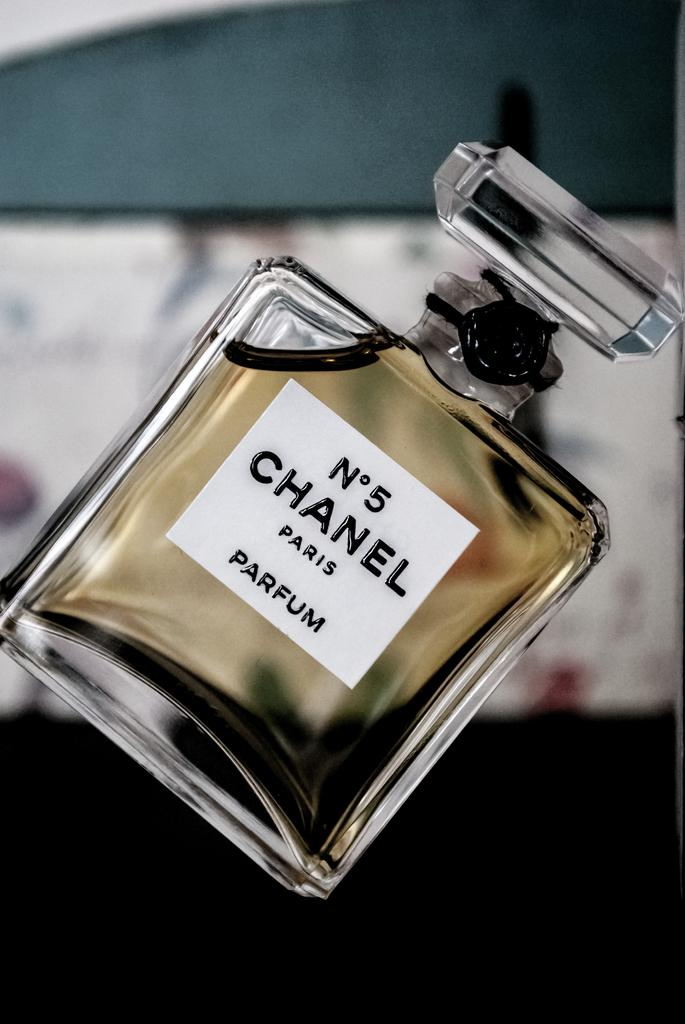<image>
Summarize the visual content of the image. A full bottle of Chanel No 5 perfume is show at an angle. 